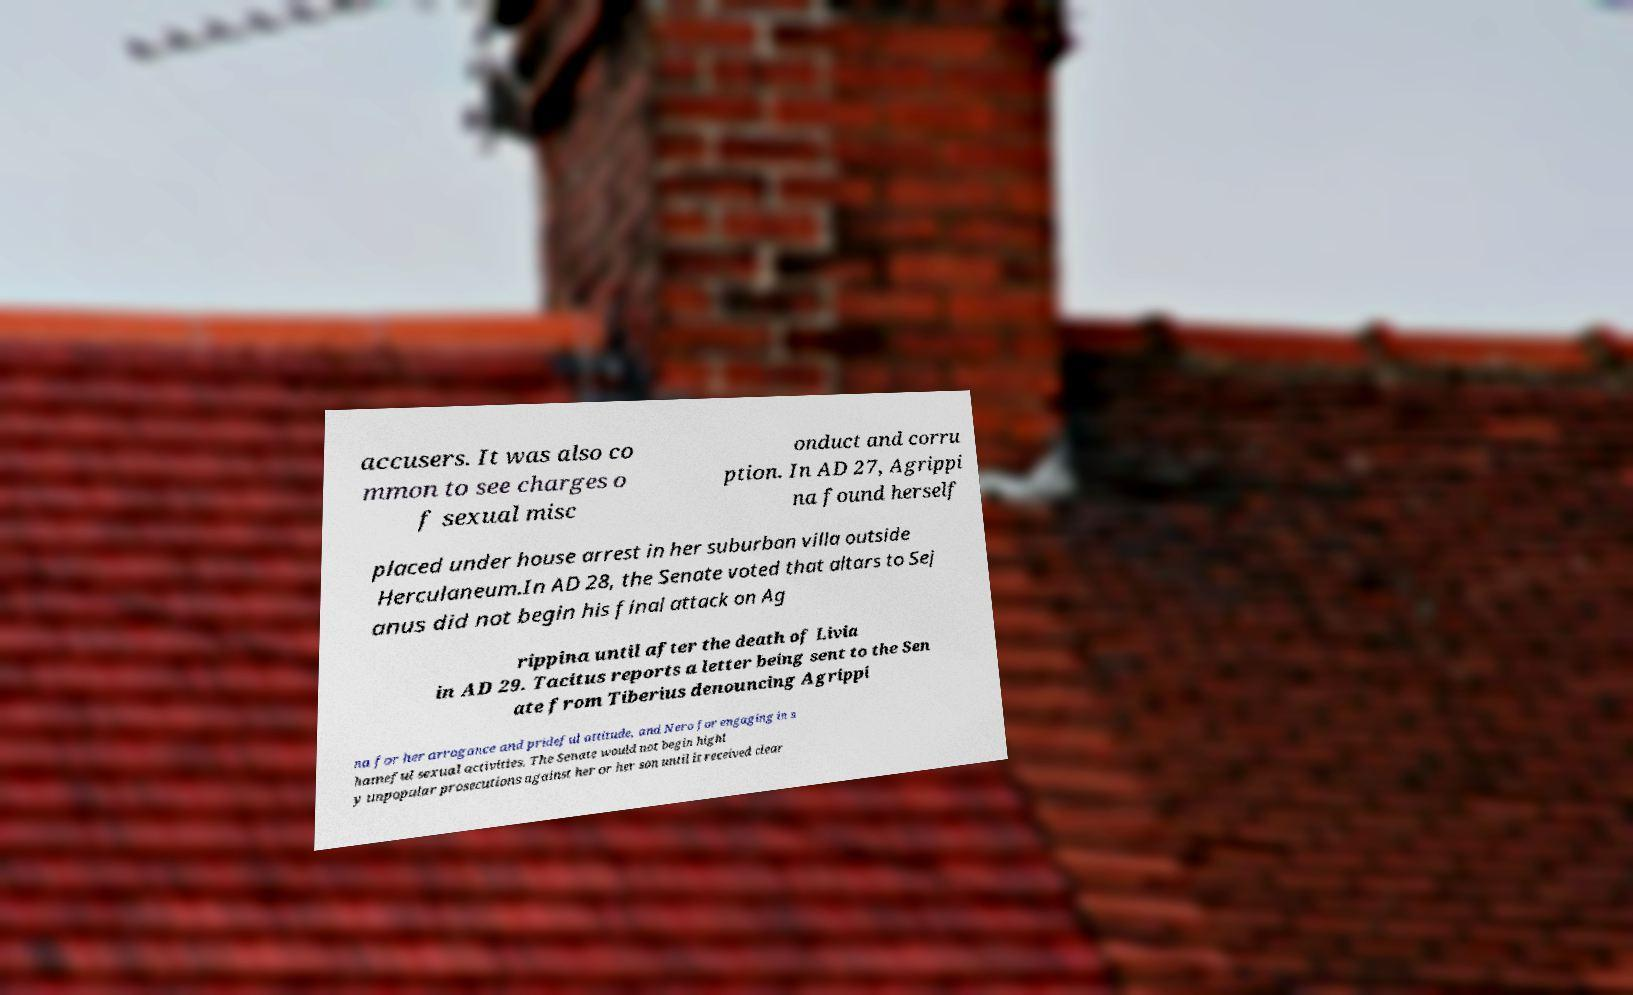Could you extract and type out the text from this image? accusers. It was also co mmon to see charges o f sexual misc onduct and corru ption. In AD 27, Agrippi na found herself placed under house arrest in her suburban villa outside Herculaneum.In AD 28, the Senate voted that altars to Sej anus did not begin his final attack on Ag rippina until after the death of Livia in AD 29. Tacitus reports a letter being sent to the Sen ate from Tiberius denouncing Agrippi na for her arrogance and prideful attitude, and Nero for engaging in s hameful sexual activities. The Senate would not begin highl y unpopular prosecutions against her or her son until it received clear 